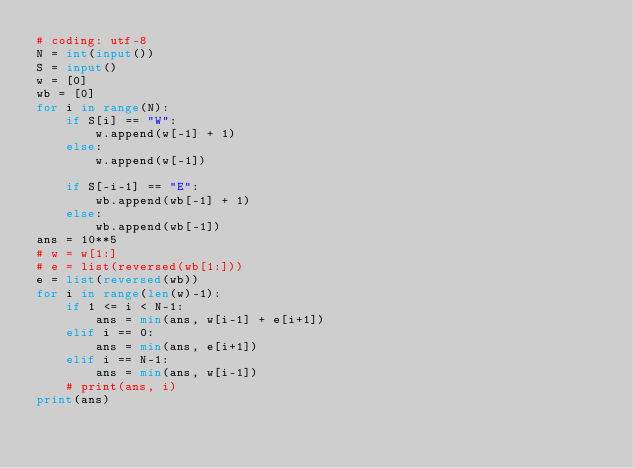<code> <loc_0><loc_0><loc_500><loc_500><_Python_># coding: utf-8
N = int(input())
S = input()
w = [0]
wb = [0]
for i in range(N):
    if S[i] == "W":
        w.append(w[-1] + 1)
    else:
        w.append(w[-1])
    
    if S[-i-1] == "E":
        wb.append(wb[-1] + 1)
    else:
        wb.append(wb[-1])
ans = 10**5
# w = w[1:]
# e = list(reversed(wb[1:]))
e = list(reversed(wb))
for i in range(len(w)-1):
    if 1 <= i < N-1:
        ans = min(ans, w[i-1] + e[i+1])
    elif i == 0:
        ans = min(ans, e[i+1])
    elif i == N-1:
        ans = min(ans, w[i-1])
    # print(ans, i)
print(ans)

</code> 